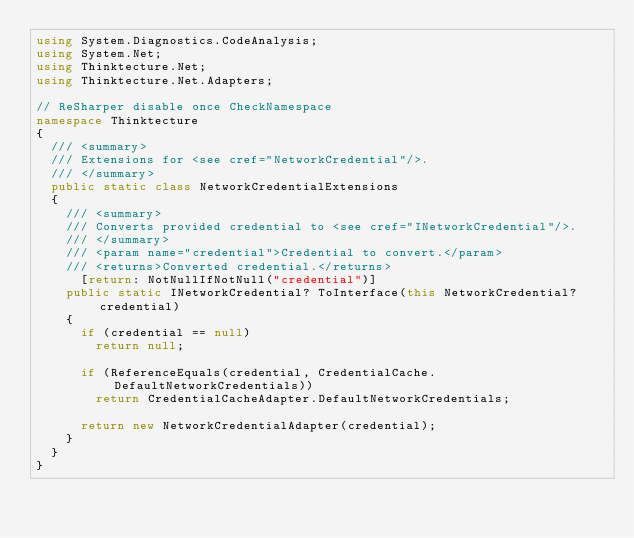<code> <loc_0><loc_0><loc_500><loc_500><_C#_>using System.Diagnostics.CodeAnalysis;
using System.Net;
using Thinktecture.Net;
using Thinktecture.Net.Adapters;

// ReSharper disable once CheckNamespace
namespace Thinktecture
{
	/// <summary>
	/// Extensions for <see cref="NetworkCredential"/>.
	/// </summary>
	public static class NetworkCredentialExtensions
	{
		/// <summary>
		/// Converts provided credential to <see cref="INetworkCredential"/>.
		/// </summary>
		/// <param name="credential">Credential to convert.</param>
		/// <returns>Converted credential.</returns>
      [return: NotNullIfNotNull("credential")]
		public static INetworkCredential? ToInterface(this NetworkCredential? credential)
		{
			if (credential == null)
				return null;

			if (ReferenceEquals(credential, CredentialCache.DefaultNetworkCredentials))
				return CredentialCacheAdapter.DefaultNetworkCredentials;

			return new NetworkCredentialAdapter(credential);
		}
	}
}
</code> 